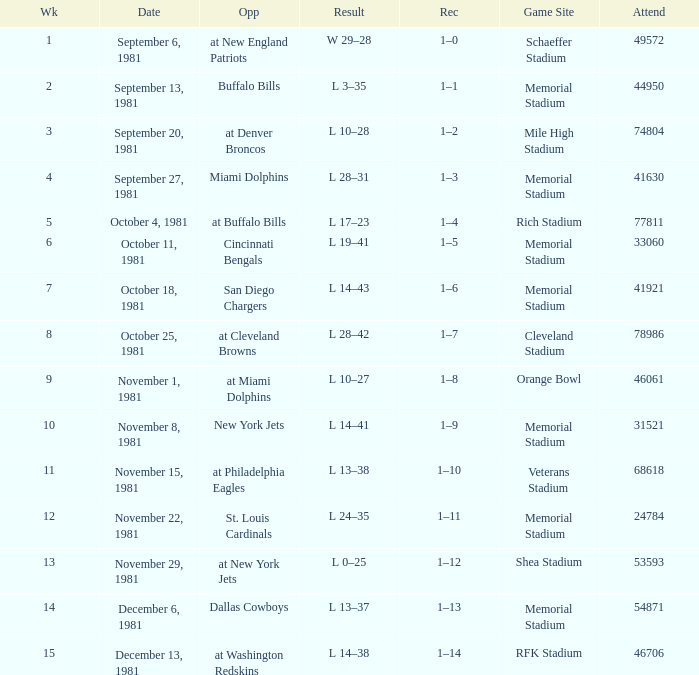When it is week 2 what is the record? 1–1. 